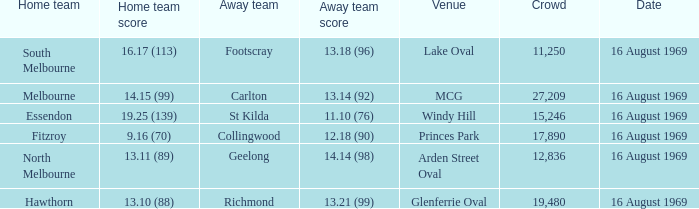What was the away team when the game was at Princes Park? Collingwood. 